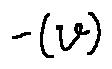Convert formula to latex. <formula><loc_0><loc_0><loc_500><loc_500>- ( v )</formula> 